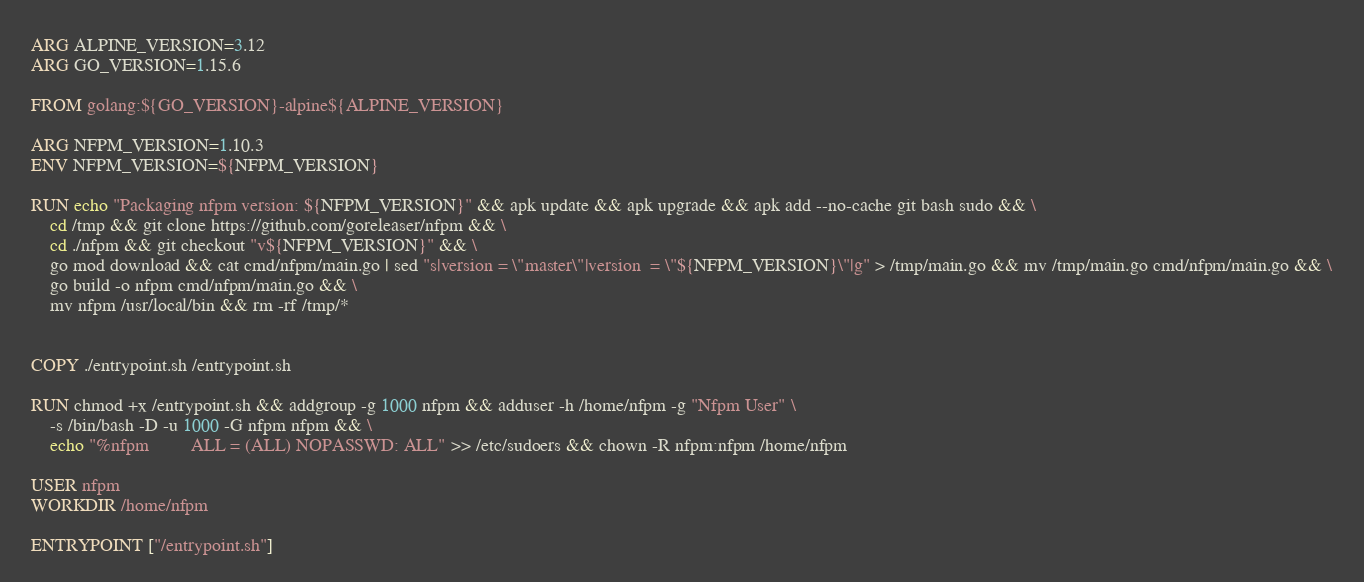Convert code to text. <code><loc_0><loc_0><loc_500><loc_500><_Dockerfile_>ARG ALPINE_VERSION=3.12
ARG GO_VERSION=1.15.6

FROM golang:${GO_VERSION}-alpine${ALPINE_VERSION}

ARG NFPM_VERSION=1.10.3
ENV NFPM_VERSION=${NFPM_VERSION}

RUN echo "Packaging nfpm version: ${NFPM_VERSION}" && apk update && apk upgrade && apk add --no-cache git bash sudo && \
    cd /tmp && git clone https://github.com/goreleaser/nfpm && \
    cd ./nfpm && git checkout "v${NFPM_VERSION}" && \
    go mod download && cat cmd/nfpm/main.go | sed "s|version = \"master\"|version  = \"${NFPM_VERSION}\"|g" > /tmp/main.go && mv /tmp/main.go cmd/nfpm/main.go && \
    go build -o nfpm cmd/nfpm/main.go && \
    mv nfpm /usr/local/bin && rm -rf /tmp/*


COPY ./entrypoint.sh /entrypoint.sh

RUN chmod +x /entrypoint.sh && addgroup -g 1000 nfpm && adduser -h /home/nfpm -g "Nfpm User" \
    -s /bin/bash -D -u 1000 -G nfpm nfpm && \
    echo "%nfpm         ALL = (ALL) NOPASSWD: ALL" >> /etc/sudoers && chown -R nfpm:nfpm /home/nfpm

USER nfpm
WORKDIR /home/nfpm

ENTRYPOINT ["/entrypoint.sh"]</code> 